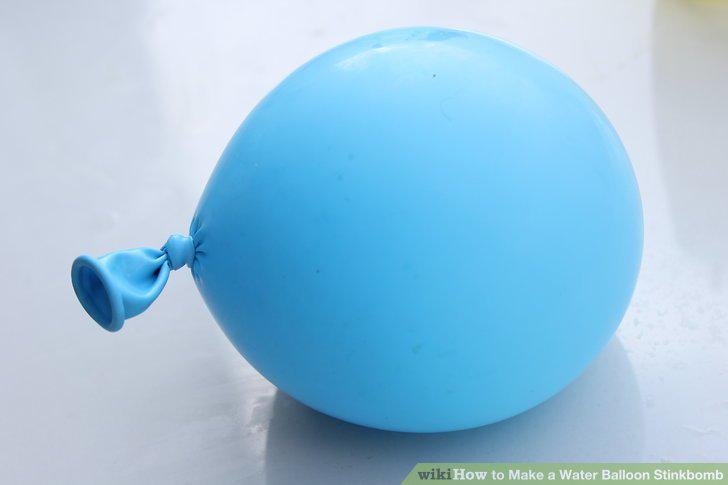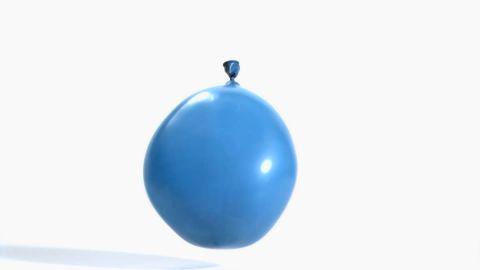The first image is the image on the left, the second image is the image on the right. Given the left and right images, does the statement "One of the balloons is bright pink." hold true? Answer yes or no. No. The first image is the image on the left, the second image is the image on the right. Evaluate the accuracy of this statement regarding the images: "One image includes a lumpy-looking green balloon, and the other image includes at least two balloons of different colors.". Is it true? Answer yes or no. No. 